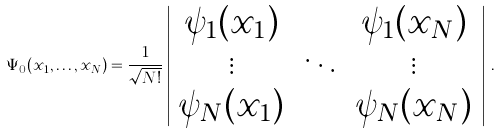Convert formula to latex. <formula><loc_0><loc_0><loc_500><loc_500>\Psi _ { 0 } ( x _ { 1 } , \dots , x _ { N } ) = \frac { 1 } { \sqrt { N ! } } \left | \begin{array} { c c c } \psi _ { 1 } ( x _ { 1 } ) & \cdots & \psi _ { 1 } ( x _ { N } ) \\ \vdots & \ddots & \vdots \\ \psi _ { N } ( x _ { 1 } ) & \cdots & \psi _ { N } ( x _ { N } ) \end{array} \right | \, .</formula> 